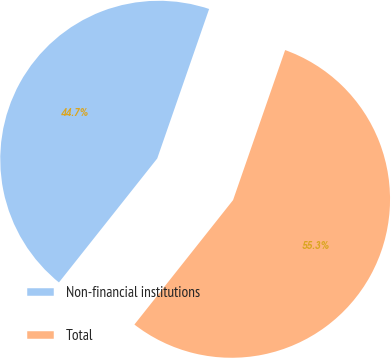Convert chart to OTSL. <chart><loc_0><loc_0><loc_500><loc_500><pie_chart><fcel>Non-financial institutions<fcel>Total<nl><fcel>44.65%<fcel>55.35%<nl></chart> 